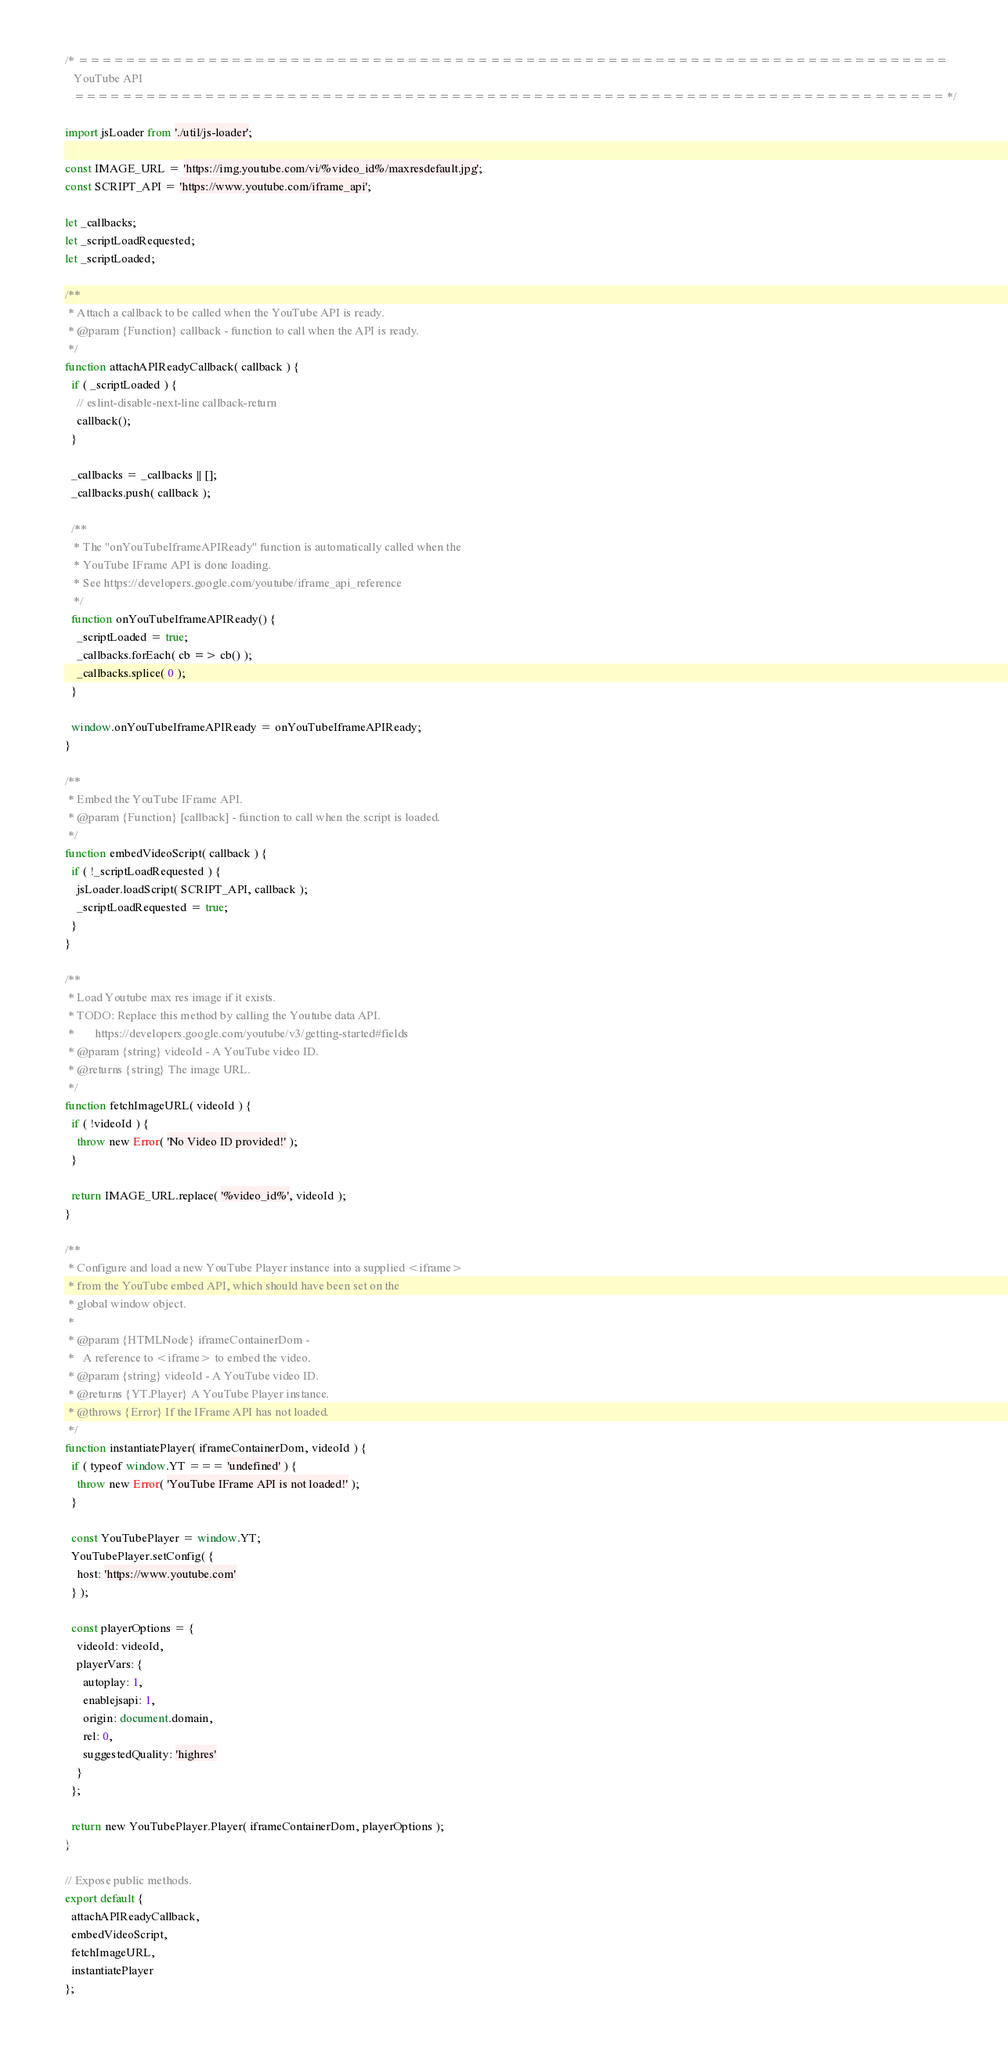Convert code to text. <code><loc_0><loc_0><loc_500><loc_500><_JavaScript_>/* ==========================================================================
   YouTube API
   ========================================================================== */

import jsLoader from './util/js-loader';

const IMAGE_URL = 'https://img.youtube.com/vi/%video_id%/maxresdefault.jpg';
const SCRIPT_API = 'https://www.youtube.com/iframe_api';

let _callbacks;
let _scriptLoadRequested;
let _scriptLoaded;

/**
 * Attach a callback to be called when the YouTube API is ready.
 * @param {Function} callback - function to call when the API is ready.
 */
function attachAPIReadyCallback( callback ) {
  if ( _scriptLoaded ) {
    // eslint-disable-next-line callback-return
    callback();
  }

  _callbacks = _callbacks || [];
  _callbacks.push( callback );

  /**
   * The "onYouTubeIframeAPIReady" function is automatically called when the
   * YouTube IFrame API is done loading.
   * See https://developers.google.com/youtube/iframe_api_reference
   */
  function onYouTubeIframeAPIReady() {
    _scriptLoaded = true;
    _callbacks.forEach( cb => cb() );
    _callbacks.splice( 0 );
  }

  window.onYouTubeIframeAPIReady = onYouTubeIframeAPIReady;
}

/**
 * Embed the YouTube IFrame API.
 * @param {Function} [callback] - function to call when the script is loaded.
 */
function embedVideoScript( callback ) {
  if ( !_scriptLoadRequested ) {
    jsLoader.loadScript( SCRIPT_API, callback );
    _scriptLoadRequested = true;
  }
}

/**
 * Load Youtube max res image if it exists.
 * TODO: Replace this method by calling the Youtube data API.
 *       https://developers.google.com/youtube/v3/getting-started#fields
 * @param {string} videoId - A YouTube video ID.
 * @returns {string} The image URL.
 */
function fetchImageURL( videoId ) {
  if ( !videoId ) {
    throw new Error( 'No Video ID provided!' );
  }

  return IMAGE_URL.replace( '%video_id%', videoId );
}

/**
 * Configure and load a new YouTube Player instance into a supplied <iframe>
 * from the YouTube embed API, which should have been set on the
 * global window object.
 *
 * @param {HTMLNode} iframeContainerDom -
 *   A reference to <iframe> to embed the video.
 * @param {string} videoId - A YouTube video ID.
 * @returns {YT.Player} A YouTube Player instance.
 * @throws {Error} If the IFrame API has not loaded.
 */
function instantiatePlayer( iframeContainerDom, videoId ) {
  if ( typeof window.YT === 'undefined' ) {
    throw new Error( 'YouTube IFrame API is not loaded!' );
  }

  const YouTubePlayer = window.YT;
  YouTubePlayer.setConfig( {
    host: 'https://www.youtube.com'
  } );

  const playerOptions = {
    videoId: videoId,
    playerVars: {
      autoplay: 1,
      enablejsapi: 1,
      origin: document.domain,
      rel: 0,
      suggestedQuality: 'highres'
    }
  };

  return new YouTubePlayer.Player( iframeContainerDom, playerOptions );
}

// Expose public methods.
export default {
  attachAPIReadyCallback,
  embedVideoScript,
  fetchImageURL,
  instantiatePlayer
};
</code> 